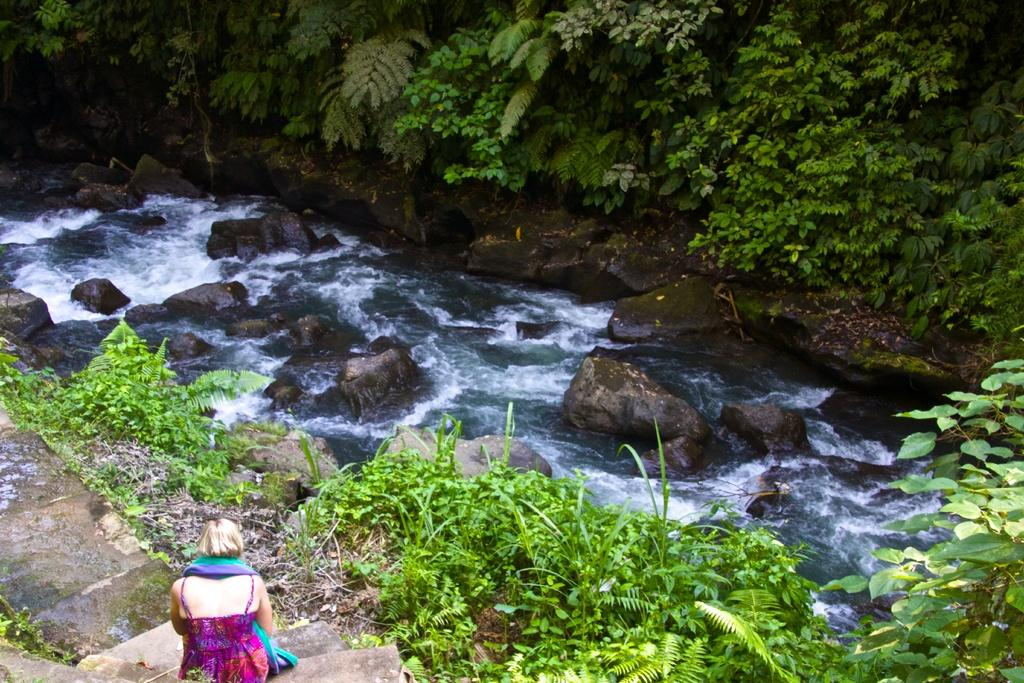What is one of the natural elements present in the image? There is water in the image. What other natural elements can be seen in the image? There are stones, grass, and trees in the image. What is the woman in the image doing? The woman is sitting in the image. How is the woman dressed? The woman is wearing a colorful dress. What type of story is the woman reading to the mice in the image? There are no mice present in the image, and the woman is not reading a story. 